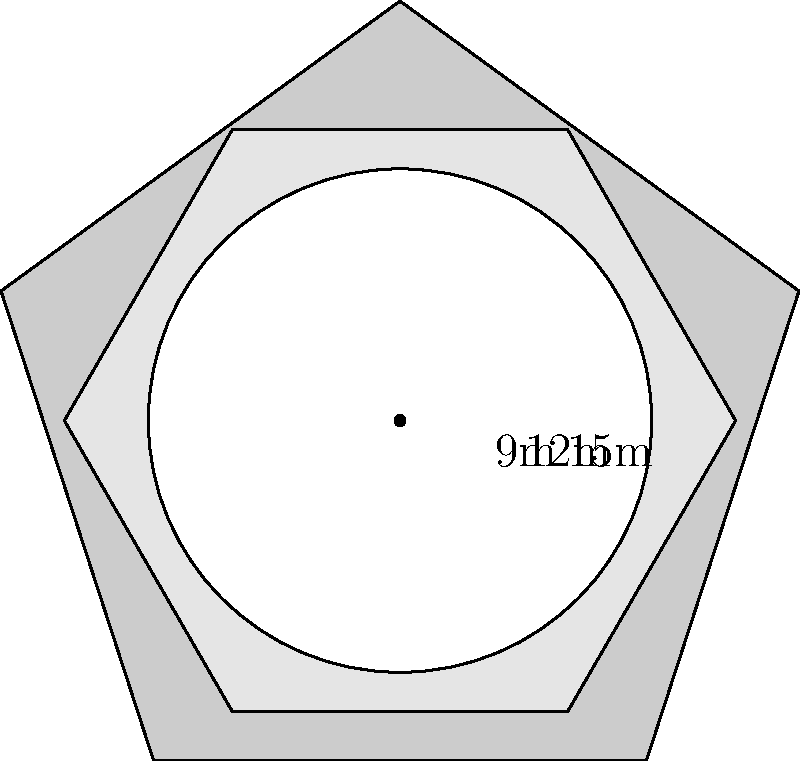Your multi-level terrace is the envy of the neighborhood. It consists of three levels: a pentagonal base, a hexagonal middle level, and a circular top level. The side length of the pentagonal base is 15m, the side length of the hexagonal middle level is 12m, and the radius of the circular top level is 9m. What is the total area of all three levels combined? Let's calculate the area of each level separately:

1. Pentagonal base:
   Area of a regular pentagon = $\frac{1}{4}\sqrt{25+10\sqrt{5}}s^2$, where $s$ is the side length
   $A_1 = \frac{1}{4}\sqrt{25+10\sqrt{5}}(15)^2 = 481.61m^2$

2. Hexagonal middle level:
   Area of a regular hexagon = $\frac{3\sqrt{3}}{2}s^2$, where $s$ is the side length
   $A_2 = \frac{3\sqrt{3}}{2}(12)^2 = 374.37m^2$

3. Circular top level:
   Area of a circle = $\pi r^2$, where $r$ is the radius
   $A_3 = \pi(9)^2 = 254.47m^2$

Total area = $A_1 + A_2 + A_3$
           = $481.61 + 374.37 + 254.47$
           = $1110.45m^2$
Answer: $1110.45m^2$ 